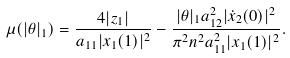Convert formula to latex. <formula><loc_0><loc_0><loc_500><loc_500>\mu ( | \theta | _ { 1 } ) = \frac { 4 | z _ { 1 } | } { a _ { 1 1 } | x _ { 1 } ( 1 ) | ^ { 2 } } - \frac { | \theta | _ { 1 } a ^ { 2 } _ { 1 2 } | \dot { x } _ { 2 } ( 0 ) | ^ { 2 } } { \pi ^ { 2 } n ^ { 2 } a ^ { 2 } _ { 1 1 } | x _ { 1 } ( 1 ) | ^ { 2 } } .</formula> 